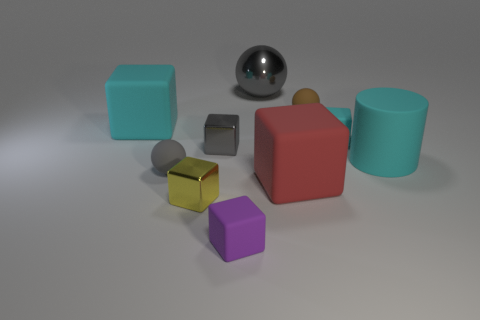How many big objects have the same material as the small purple thing?
Provide a short and direct response. 3. What is the shape of the cyan object that is both to the right of the yellow cube and left of the big rubber cylinder?
Ensure brevity in your answer.  Cube. Is the material of the big cyan cube behind the big red thing the same as the big cylinder?
Ensure brevity in your answer.  Yes. Are there any other things that have the same material as the yellow cube?
Offer a terse response. Yes. What color is the matte sphere that is the same size as the brown thing?
Keep it short and to the point. Gray. Are there any large metal things that have the same color as the large metallic ball?
Provide a succinct answer. No. What is the size of the purple thing that is made of the same material as the brown ball?
Ensure brevity in your answer.  Small. What size is the block that is the same color as the large ball?
Your answer should be compact. Small. What number of other things are there of the same size as the brown matte sphere?
Your answer should be very brief. 5. What material is the tiny block to the right of the small purple block?
Make the answer very short. Rubber. 